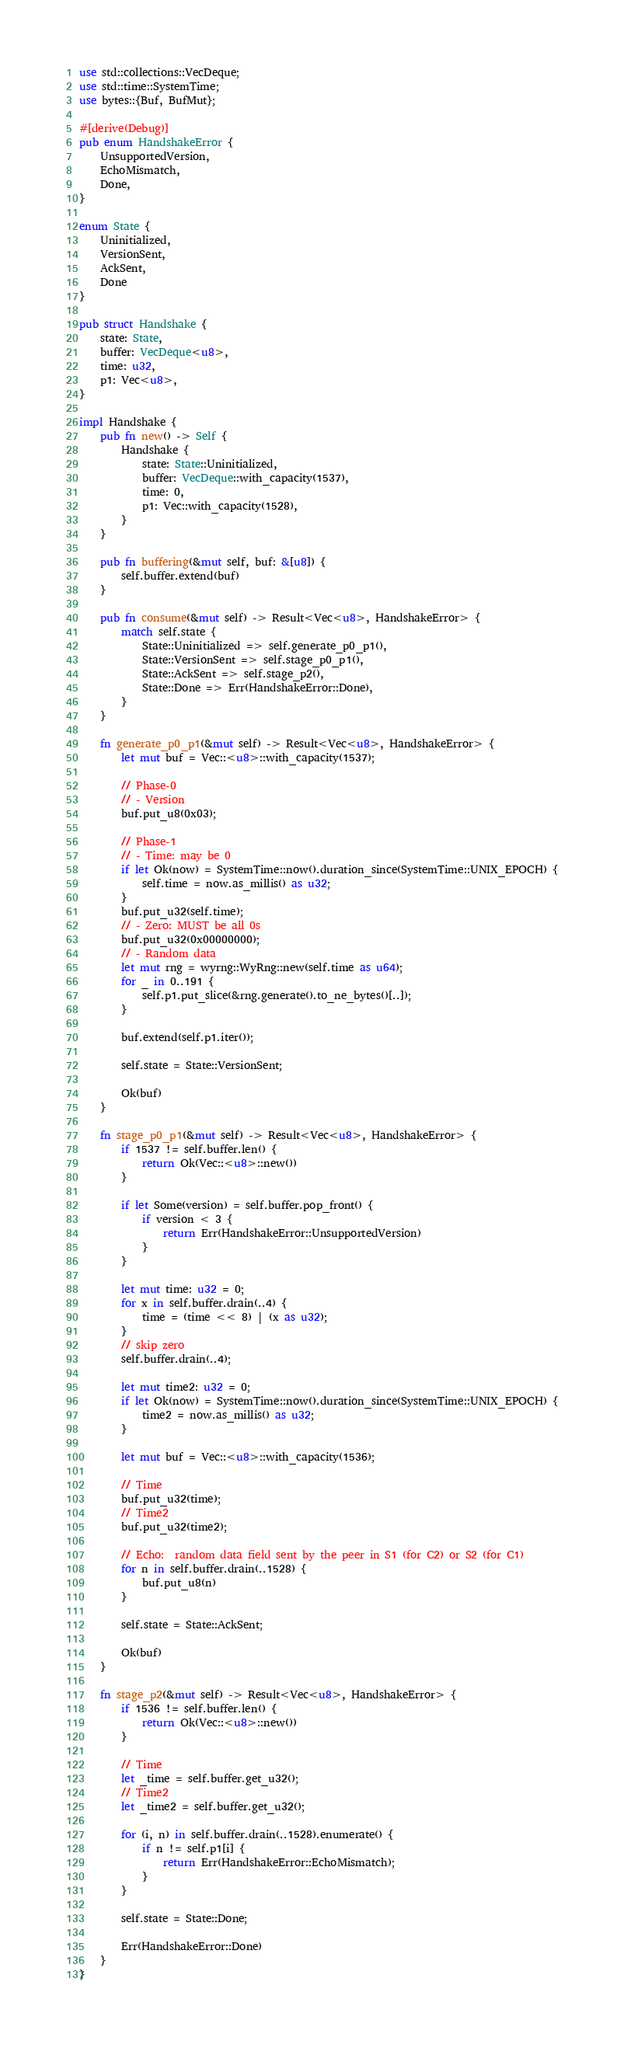<code> <loc_0><loc_0><loc_500><loc_500><_Rust_>use std::collections::VecDeque;
use std::time::SystemTime;
use bytes::{Buf, BufMut};

#[derive(Debug)]
pub enum HandshakeError {
    UnsupportedVersion,
    EchoMismatch,
    Done,
}

enum State {
    Uninitialized,
    VersionSent,
    AckSent,
    Done
}

pub struct Handshake {
    state: State,
    buffer: VecDeque<u8>,
    time: u32,
    p1: Vec<u8>,
}

impl Handshake {
    pub fn new() -> Self {
        Handshake {
            state: State::Uninitialized,
            buffer: VecDeque::with_capacity(1537),
            time: 0,
            p1: Vec::with_capacity(1528),
        }
    }

    pub fn buffering(&mut self, buf: &[u8]) {
        self.buffer.extend(buf)
    }

    pub fn consume(&mut self) -> Result<Vec<u8>, HandshakeError> {
        match self.state {
            State::Uninitialized => self.generate_p0_p1(),
            State::VersionSent => self.stage_p0_p1(),
            State::AckSent => self.stage_p2(),
            State::Done => Err(HandshakeError::Done),
        }
    }

    fn generate_p0_p1(&mut self) -> Result<Vec<u8>, HandshakeError> {
        let mut buf = Vec::<u8>::with_capacity(1537);

        // Phase-0
        // - Version
        buf.put_u8(0x03);

        // Phase-1
        // - Time: may be 0
        if let Ok(now) = SystemTime::now().duration_since(SystemTime::UNIX_EPOCH) {
            self.time = now.as_millis() as u32;
        }
        buf.put_u32(self.time);
        // - Zero: MUST be all 0s
        buf.put_u32(0x00000000);
        // - Random data
        let mut rng = wyrng::WyRng::new(self.time as u64);
        for _ in 0..191 {
            self.p1.put_slice(&rng.generate().to_ne_bytes()[..]);
        }

        buf.extend(self.p1.iter());

        self.state = State::VersionSent;

        Ok(buf)
    }

    fn stage_p0_p1(&mut self) -> Result<Vec<u8>, HandshakeError> {
        if 1537 != self.buffer.len() {
            return Ok(Vec::<u8>::new())
        }

        if let Some(version) = self.buffer.pop_front() {
            if version < 3 {
                return Err(HandshakeError::UnsupportedVersion)
            }
        }

        let mut time: u32 = 0;
        for x in self.buffer.drain(..4) {
            time = (time << 8) | (x as u32);
        }
        // skip zero
        self.buffer.drain(..4);

        let mut time2: u32 = 0;
        if let Ok(now) = SystemTime::now().duration_since(SystemTime::UNIX_EPOCH) {
            time2 = now.as_millis() as u32;
        }

        let mut buf = Vec::<u8>::with_capacity(1536);

        // Time
        buf.put_u32(time);
        // Time2
        buf.put_u32(time2);

        // Echo:  random data field sent by the peer in S1 (for C2) or S2 (for C1)
        for n in self.buffer.drain(..1528) {
            buf.put_u8(n)
        }

        self.state = State::AckSent;

        Ok(buf)
    }

    fn stage_p2(&mut self) -> Result<Vec<u8>, HandshakeError> {
        if 1536 != self.buffer.len() {
            return Ok(Vec::<u8>::new())
        }

        // Time
        let _time = self.buffer.get_u32();
        // Time2
        let _time2 = self.buffer.get_u32();

        for (i, n) in self.buffer.drain(..1528).enumerate() {
            if n != self.p1[i] {
                return Err(HandshakeError::EchoMismatch);
            }
        }

        self.state = State::Done;

        Err(HandshakeError::Done)
    }
}
</code> 